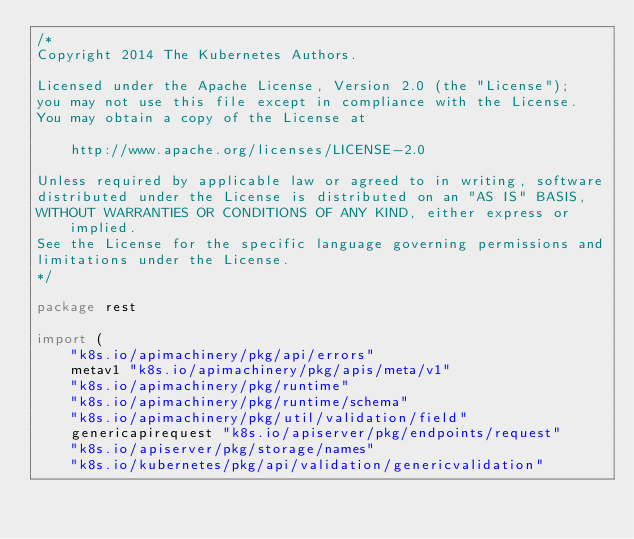Convert code to text. <code><loc_0><loc_0><loc_500><loc_500><_Go_>/*
Copyright 2014 The Kubernetes Authors.

Licensed under the Apache License, Version 2.0 (the "License");
you may not use this file except in compliance with the License.
You may obtain a copy of the License at

    http://www.apache.org/licenses/LICENSE-2.0

Unless required by applicable law or agreed to in writing, software
distributed under the License is distributed on an "AS IS" BASIS,
WITHOUT WARRANTIES OR CONDITIONS OF ANY KIND, either express or implied.
See the License for the specific language governing permissions and
limitations under the License.
*/

package rest

import (
	"k8s.io/apimachinery/pkg/api/errors"
	metav1 "k8s.io/apimachinery/pkg/apis/meta/v1"
	"k8s.io/apimachinery/pkg/runtime"
	"k8s.io/apimachinery/pkg/runtime/schema"
	"k8s.io/apimachinery/pkg/util/validation/field"
	genericapirequest "k8s.io/apiserver/pkg/endpoints/request"
	"k8s.io/apiserver/pkg/storage/names"
	"k8s.io/kubernetes/pkg/api/validation/genericvalidation"</code> 